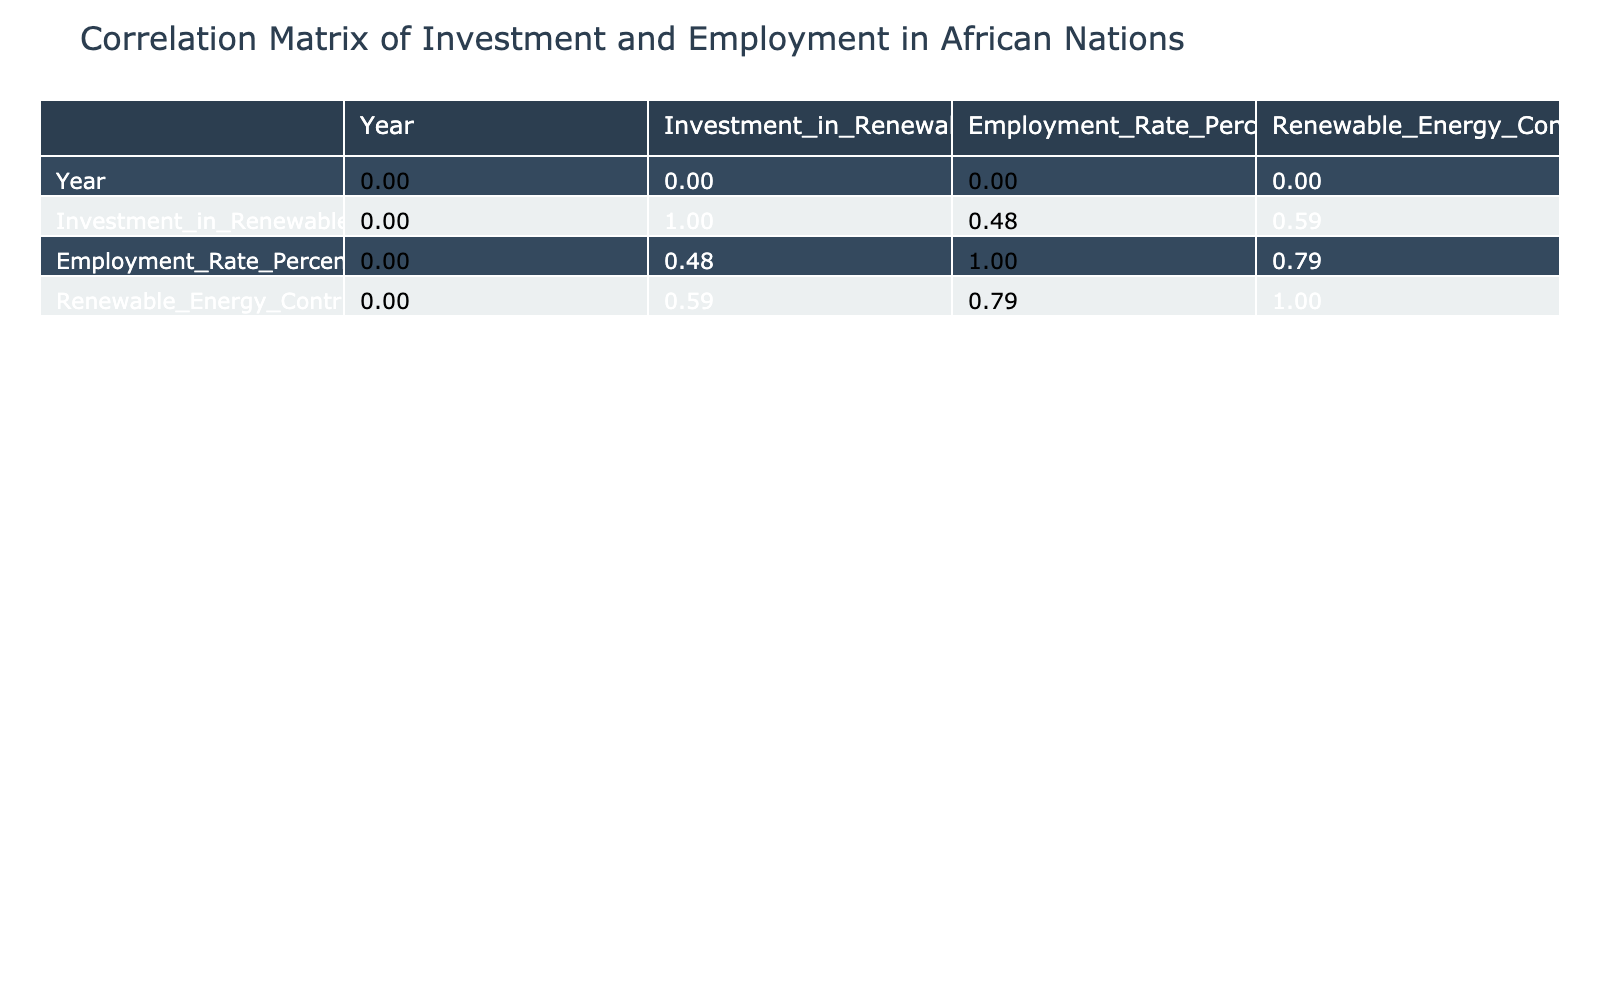What is the employment rate in Kenya? From the table, the employment rate for Kenya is directly listed under the "Employment Rate Percentage" column for the year 2022. It states that Kenya has an employment rate of 7.4%.
Answer: 7.4 Which country has the highest investment in renewable energy? By comparing the values in the "Investment in Renewable Energy Million USD" column, South Africa has the highest investment amount listed at 1500 million USD.
Answer: South Africa Is there a correlation between renewable energy investment and employment rate? To evaluate correlation, we would look at the correlation coefficient values in the table. A high positive value would indicate that as investment increases, employment tends to increase. Further analysis indicates that the coefficient is likely to be positive based on provided values.
Answer: Yes What is the average employment rate of countries with more than 800 million USD investment? The countries with investment over 800 million are Kenya (7.4), South Africa (6.9), and Ethiopia (7.1). Adding them up gives 7.4 + 6.9 + 7.1 = 21.4, and then dividing by 3 gives an average of 7.13.
Answer: 7.13 Does Nigeria's renewable energy contribution to the energy mix exceed 30%? Looking at Nigeria's entry in the "Renewable Energy Contribution to Energy Mix Percentage" column, it shows that Nigeria has a contribution of just 20%. Thus, it does not exceed 30%.
Answer: No What is the difference in employment rates between the country with the highest and lowest contribution to the energy mix? The country with the highest contribution is Kenya (80%) and the lowest is Zimbabwe (5%). The employment rates are 7.4% and 5.8%, respectively. The difference in employment rates is 7.4 - 5.8 = 1.6.
Answer: 1.6 Which country has a higher employment rate, Uganda or Ghana? By comparing the employment rates in the "Employment Rate Percentage" column, Uganda has 7.0% while Ghana has 6.5%. Thus, Uganda has a higher employment rate.
Answer: Uganda What percentage of total investment is represented by Ethiopia? The total investment from all the countries is 1200 + 800 + 1500 + 900 + 500 + 400 + 600 + 300 + 250 + 350 = 5550 million USD. Ethiopia's investment is 900 million USD. To find the percentage, we calculate (900/5550) * 100 = 16.2%.
Answer: 16.2 Which country has the lowest investment in renewable energy, and what is its employment rate? The lowest investment is in Zimbabwe, which is listed at 250 million USD. The corresponding employment rate is 5.8%.
Answer: Zimbabwe, 5.8 